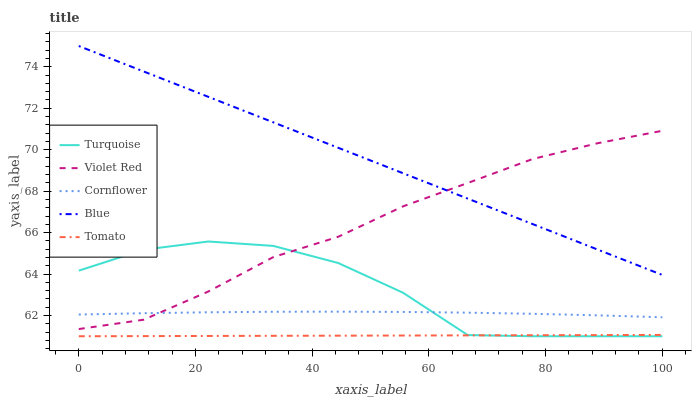Does Tomato have the minimum area under the curve?
Answer yes or no. Yes. Does Blue have the maximum area under the curve?
Answer yes or no. Yes. Does Cornflower have the minimum area under the curve?
Answer yes or no. No. Does Cornflower have the maximum area under the curve?
Answer yes or no. No. Is Tomato the smoothest?
Answer yes or no. Yes. Is Turquoise the roughest?
Answer yes or no. Yes. Is Cornflower the smoothest?
Answer yes or no. No. Is Cornflower the roughest?
Answer yes or no. No. Does Turquoise have the lowest value?
Answer yes or no. Yes. Does Cornflower have the lowest value?
Answer yes or no. No. Does Blue have the highest value?
Answer yes or no. Yes. Does Cornflower have the highest value?
Answer yes or no. No. Is Cornflower less than Blue?
Answer yes or no. Yes. Is Cornflower greater than Tomato?
Answer yes or no. Yes. Does Tomato intersect Turquoise?
Answer yes or no. Yes. Is Tomato less than Turquoise?
Answer yes or no. No. Is Tomato greater than Turquoise?
Answer yes or no. No. Does Cornflower intersect Blue?
Answer yes or no. No. 